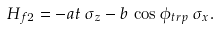<formula> <loc_0><loc_0><loc_500><loc_500>H _ { f 2 } = - a t \, \sigma _ { z } - b \, \cos \phi _ { t r p } \, \sigma _ { x } .</formula> 